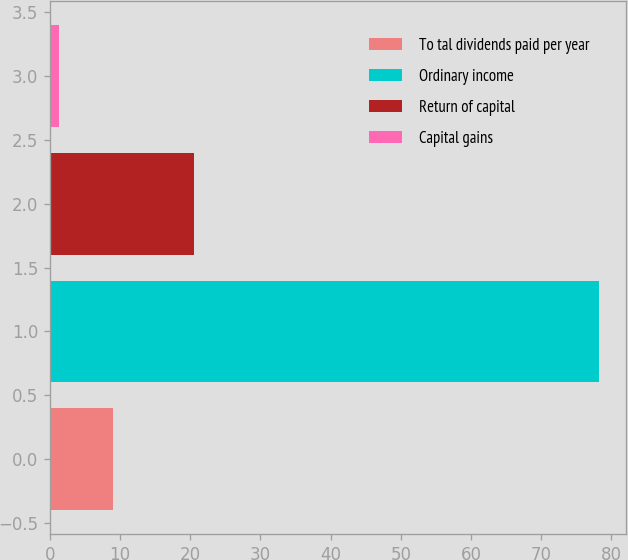<chart> <loc_0><loc_0><loc_500><loc_500><bar_chart><fcel>To tal dividends paid per year<fcel>Ordinary income<fcel>Return of capital<fcel>Capital gains<nl><fcel>8.99<fcel>78.2<fcel>20.5<fcel>1.3<nl></chart> 